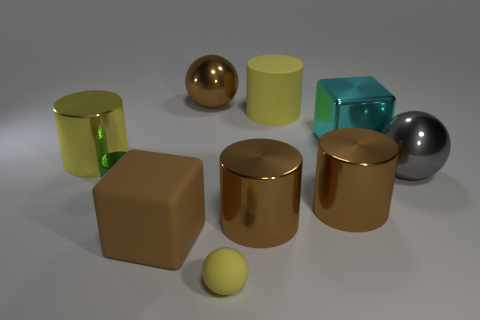The yellow matte object that is the same shape as the green object is what size?
Your answer should be very brief. Large. What size is the other cylinder that is the same color as the matte cylinder?
Make the answer very short. Large. Is there a big cyan object that has the same material as the green thing?
Keep it short and to the point. Yes. The tiny metal cylinder is what color?
Offer a terse response. Green. There is a yellow matte thing in front of the big yellow rubber cylinder; does it have the same shape as the small metallic object?
Offer a terse response. No. There is a large brown thing behind the big metal ball that is in front of the large metallic cylinder that is to the left of the big brown ball; what is its shape?
Make the answer very short. Sphere. What is the material of the ball in front of the large gray shiny object?
Ensure brevity in your answer.  Rubber. What is the color of the other ball that is the same size as the gray metallic sphere?
Give a very brief answer. Brown. What number of other things are there of the same shape as the small yellow matte thing?
Your response must be concise. 2. Do the cyan block and the brown sphere have the same size?
Provide a short and direct response. Yes. 